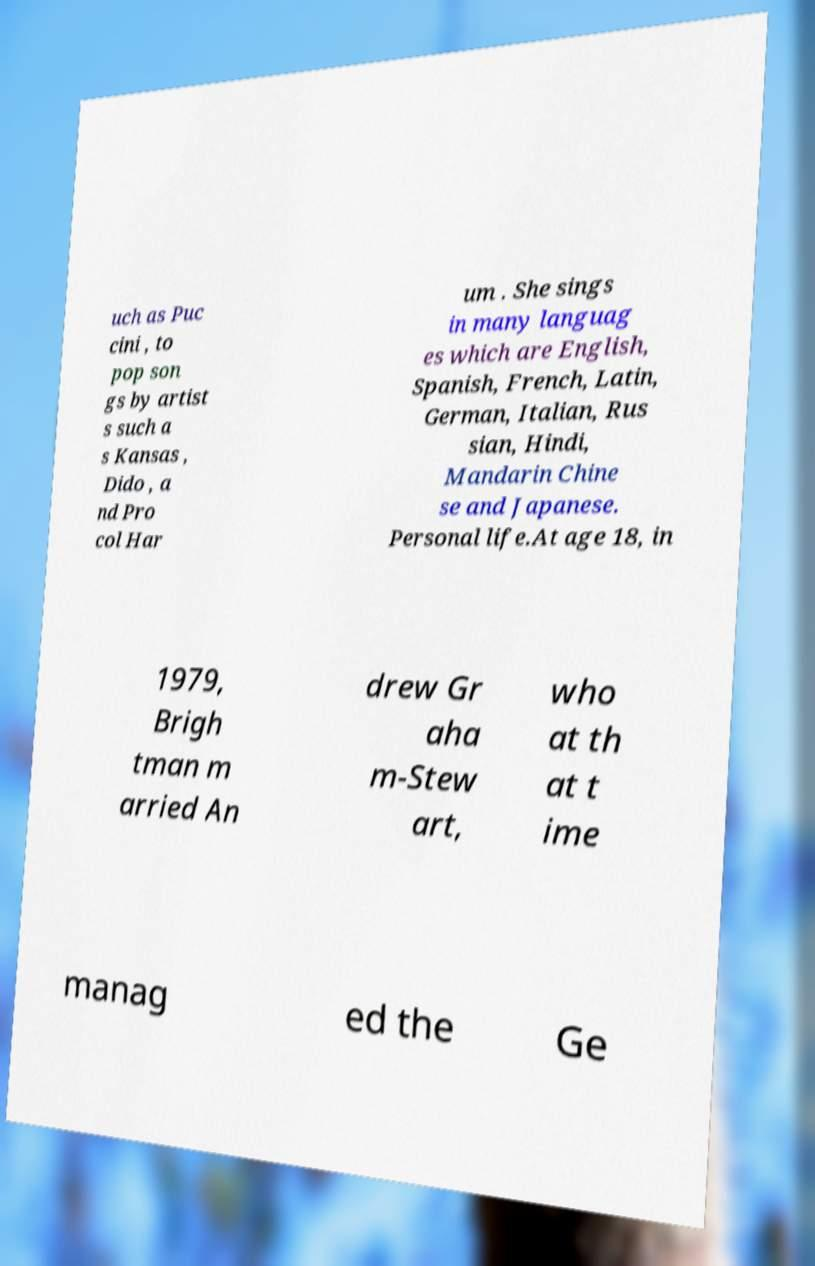Could you extract and type out the text from this image? uch as Puc cini , to pop son gs by artist s such a s Kansas , Dido , a nd Pro col Har um . She sings in many languag es which are English, Spanish, French, Latin, German, Italian, Rus sian, Hindi, Mandarin Chine se and Japanese. Personal life.At age 18, in 1979, Brigh tman m arried An drew Gr aha m-Stew art, who at th at t ime manag ed the Ge 